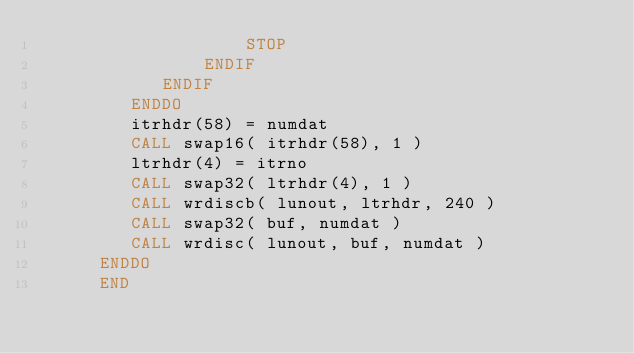<code> <loc_0><loc_0><loc_500><loc_500><_FORTRAN_>                    STOP
                ENDIF
            ENDIF
         ENDDO
         itrhdr(58) = numdat
         CALL swap16( itrhdr(58), 1 )
         ltrhdr(4) = itrno
         CALL swap32( ltrhdr(4), 1 )
         CALL wrdiscb( lunout, ltrhdr, 240 )
         CALL swap32( buf, numdat )
         CALL wrdisc( lunout, buf, numdat )
      ENDDO
      END




</code> 